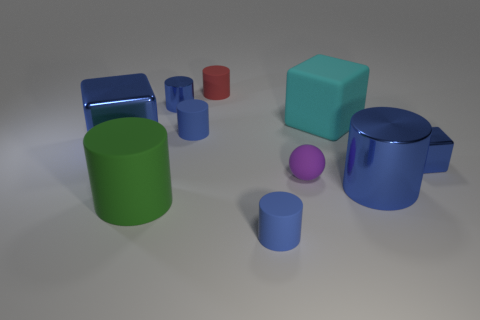Subtract all blue cylinders. How many were subtracted if there are2blue cylinders left? 2 Subtract all yellow spheres. How many blue cylinders are left? 4 Subtract 2 cylinders. How many cylinders are left? 4 Subtract all small blue shiny cylinders. How many cylinders are left? 5 Subtract all green cylinders. How many cylinders are left? 5 Subtract all red cylinders. Subtract all blue cubes. How many cylinders are left? 5 Subtract all spheres. How many objects are left? 9 Subtract all green rubber cylinders. Subtract all blue objects. How many objects are left? 3 Add 6 blue matte cylinders. How many blue matte cylinders are left? 8 Add 2 small cubes. How many small cubes exist? 3 